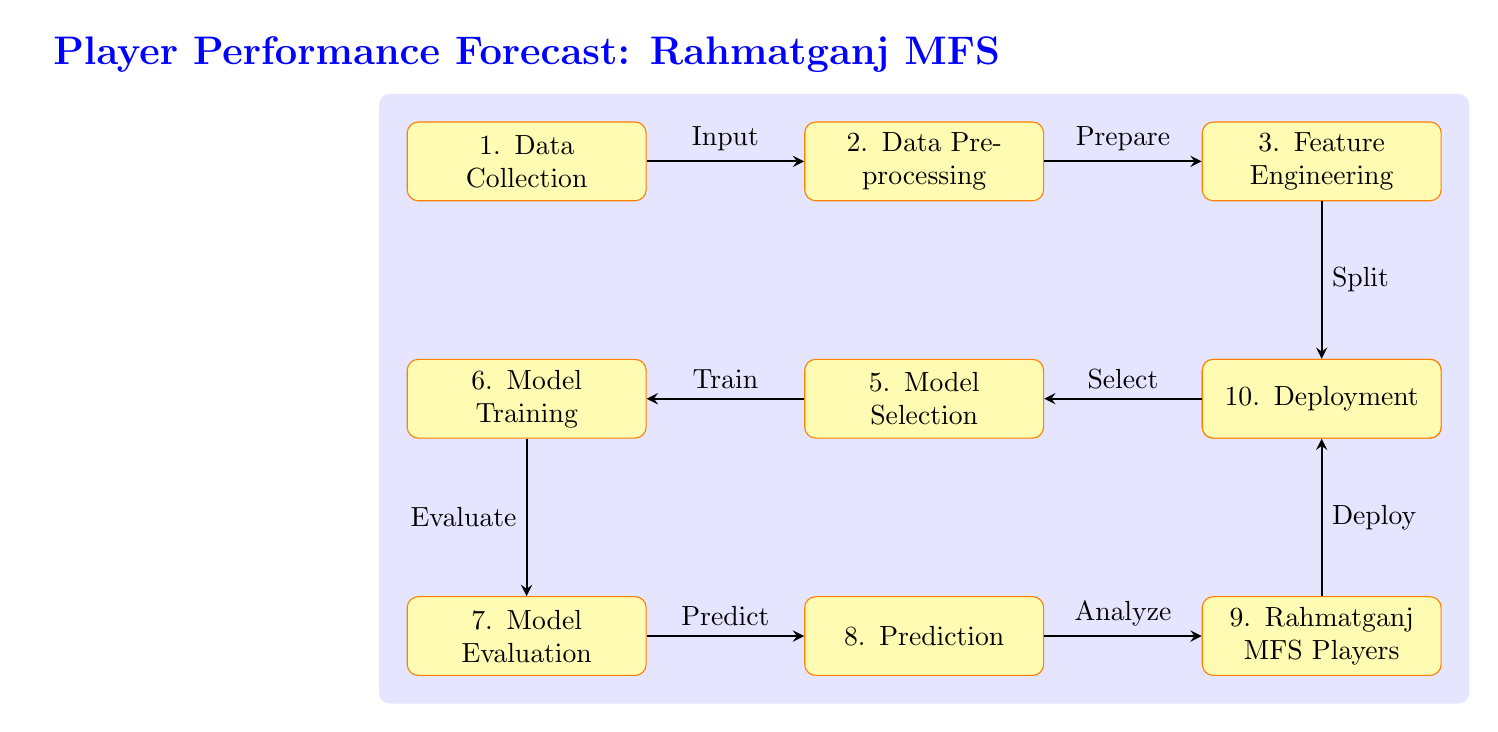What is the first step in the diagram? The diagram indicates that the first step in the process is "Data Collection." This is specifically mentioned in the node labeled as such in the diagram, marking the beginning of the process.
Answer: Data Collection How many nodes are present in the diagram? By counting all the distinct rectangles (process nodes) listed, there are a total of ten nodes in the diagram, including "Data Collection" and "Deployment."
Answer: Ten What is the output of the "Model Evaluation" node? The flow of the diagram shows that the output from the "Model Evaluation" node goes to the "Prediction" node as the next step, meaning it provides the necessary evaluations before making predictions on player performance.
Answer: Prediction What relationship exists between "Feature Engineering" and "Training Data"? The relationship is defined by the directed arrow leading from "Feature Engineering" to "Training Data," indicating that feature engineering is a process that is completed prior to the creation of the training data set.
Answer: Precedes Which node follows "Model Training"? According to the diagram's flow, the node that follows "Model Training" is "Model Evaluation." This shows that evaluation comes after the model has been trained to assess its effectiveness.
Answer: Model Evaluation What is being predicted in the last step? The final node in the sequence mentions "Rahmatganj MFS Players," indicating that the predictions made relate specifically to the performance of the Rahmatganj MFS players, focusing on their potential goals and assists.
Answer: Rahmatganj MFS Players 